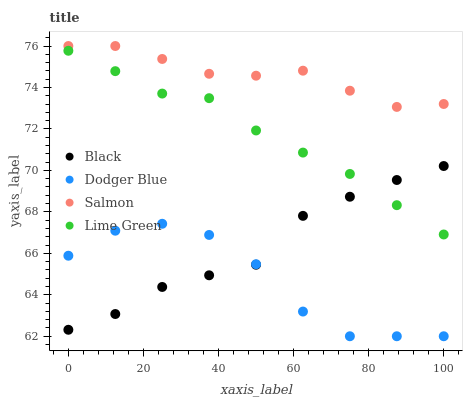Does Dodger Blue have the minimum area under the curve?
Answer yes or no. Yes. Does Salmon have the maximum area under the curve?
Answer yes or no. Yes. Does Black have the minimum area under the curve?
Answer yes or no. No. Does Black have the maximum area under the curve?
Answer yes or no. No. Is Lime Green the smoothest?
Answer yes or no. Yes. Is Dodger Blue the roughest?
Answer yes or no. Yes. Is Black the smoothest?
Answer yes or no. No. Is Black the roughest?
Answer yes or no. No. Does Dodger Blue have the lowest value?
Answer yes or no. Yes. Does Black have the lowest value?
Answer yes or no. No. Does Salmon have the highest value?
Answer yes or no. Yes. Does Black have the highest value?
Answer yes or no. No. Is Black less than Salmon?
Answer yes or no. Yes. Is Lime Green greater than Dodger Blue?
Answer yes or no. Yes. Does Dodger Blue intersect Black?
Answer yes or no. Yes. Is Dodger Blue less than Black?
Answer yes or no. No. Is Dodger Blue greater than Black?
Answer yes or no. No. Does Black intersect Salmon?
Answer yes or no. No. 